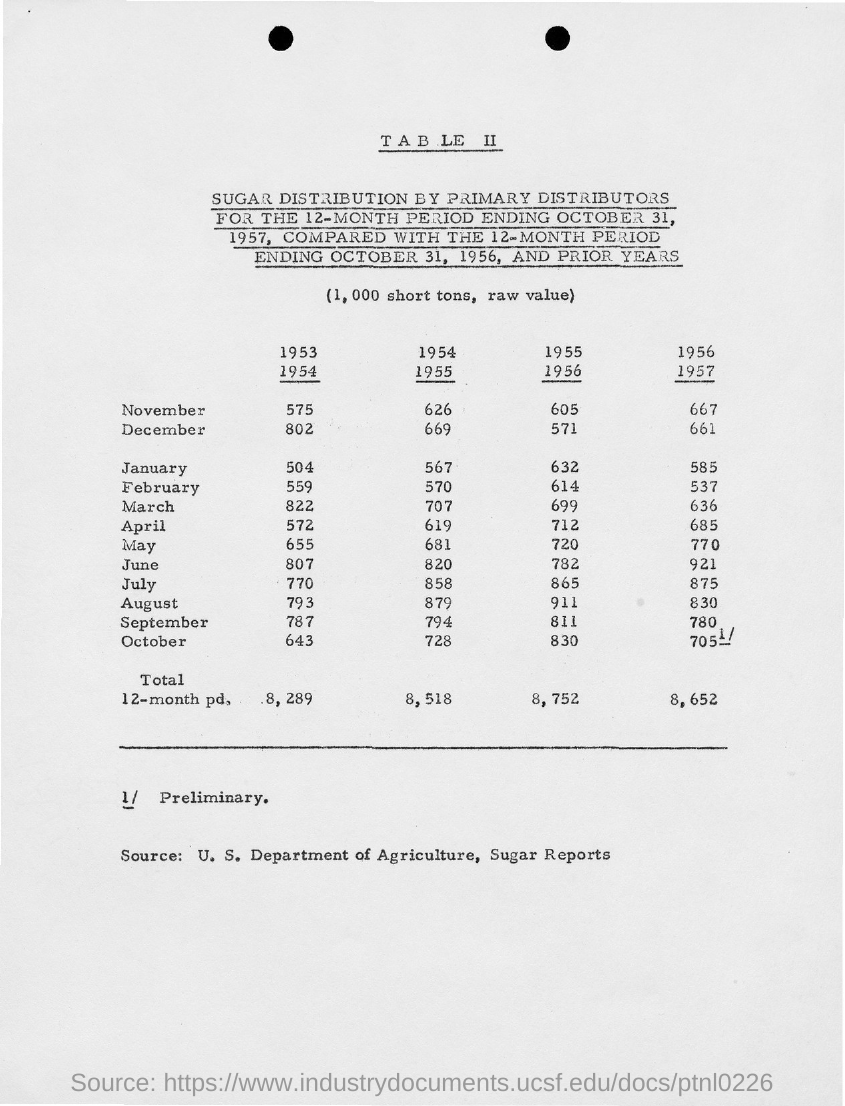Highlight a few significant elements in this photo. The total value for the years 1953 and 1954 is 8,289. 